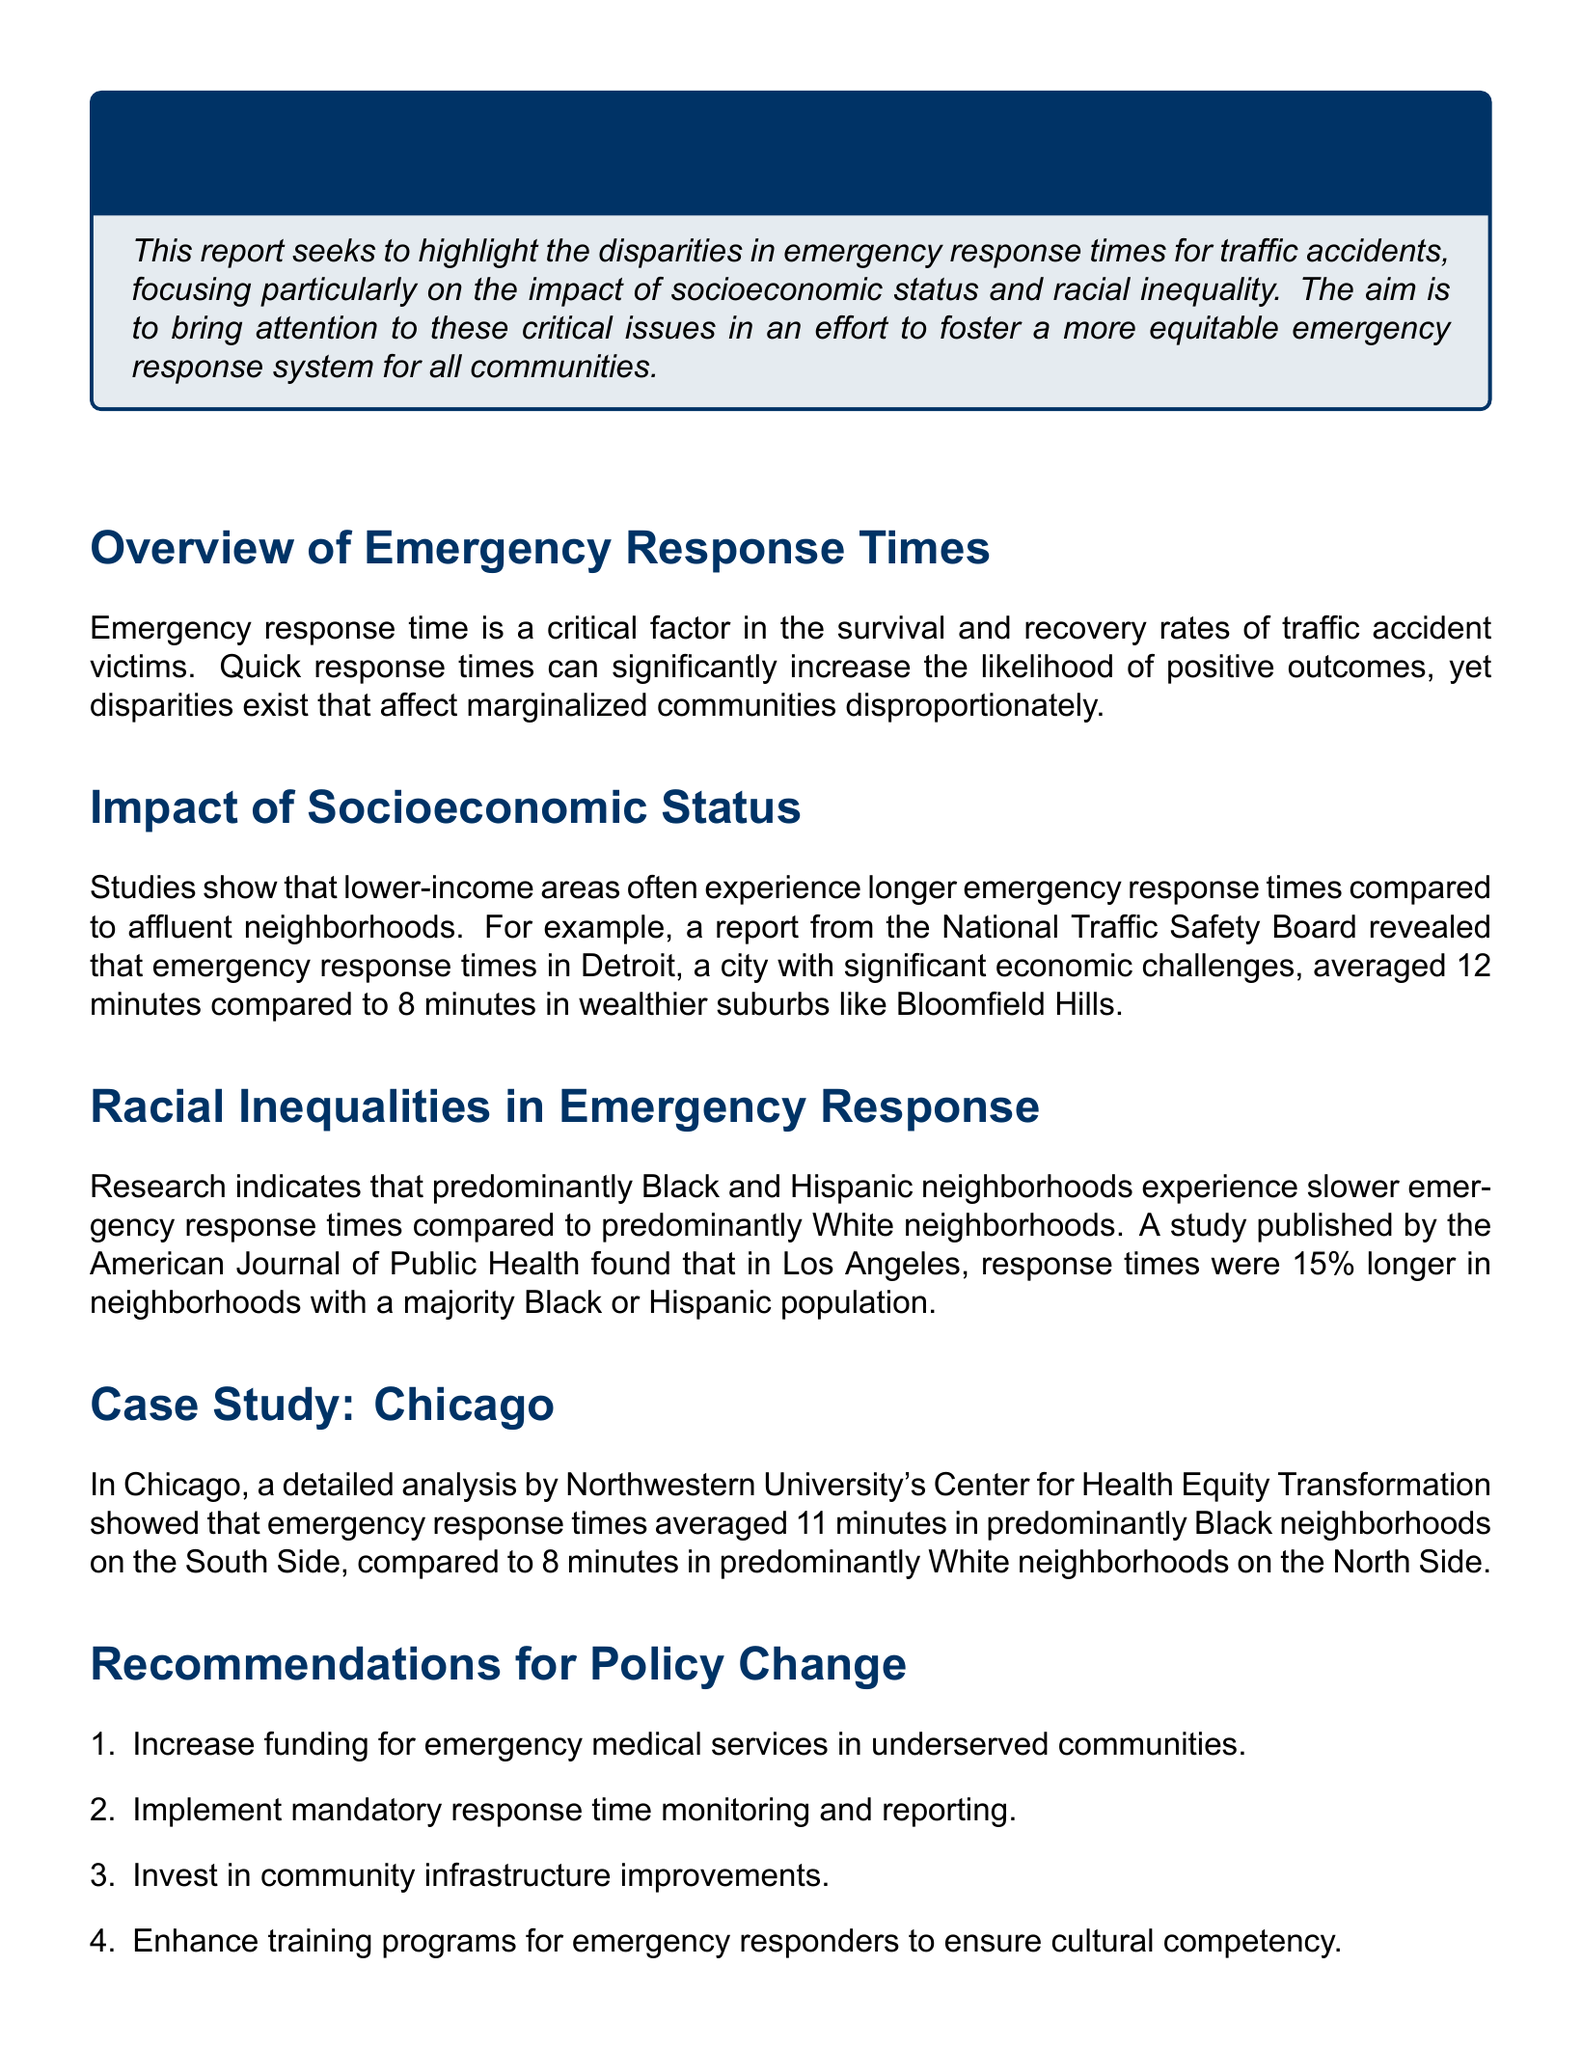what is the average emergency response time in Detroit? The document states that in Detroit, emergency response times averaged 12 minutes in lower-income areas.
Answer: 12 minutes what is the average emergency response time in affluent suburbs like Bloomfield Hills? The report indicates that affluent neighborhoods like Bloomfield Hills have an average emergency response time of 8 minutes.
Answer: 8 minutes how much longer are response times in neighborhoods with a majority Black or Hispanic population in Los Angeles? According to the document, the response times are 15% longer in neighborhoods with a majority Black or Hispanic population.
Answer: 15% what was the average emergency response time in predominantly Black neighborhoods on the South Side of Chicago? The analysis showed that emergency response times averaged 11 minutes in predominantly Black neighborhoods on the South Side.
Answer: 11 minutes what is the proposed policy for enhancing training programs for emergency responders? The recommendations for policy change include enhancing training programs for emergency responders to ensure cultural competency.
Answer: Cultural competency how do emergency response times in predominantly White neighborhoods on the North Side of Chicago compare to those on the South Side? The document states that emergency response times in predominantly White neighborhoods on the North Side averaged 8 minutes, which is 3 minutes shorter than in predominantly Black neighborhoods on the South Side.
Answer: 3 minutes shorter what type of report is documented in the traffic accident report? The document is focused on examining socioeconomic and racial inequalities in emergency response times.
Answer: Socioeconomic and racial inequalities what organization published the study referenced regarding Los Angeles response times? The study about response times in Los Angeles was published by the American Journal of Public Health.
Answer: American Journal of Public Health 